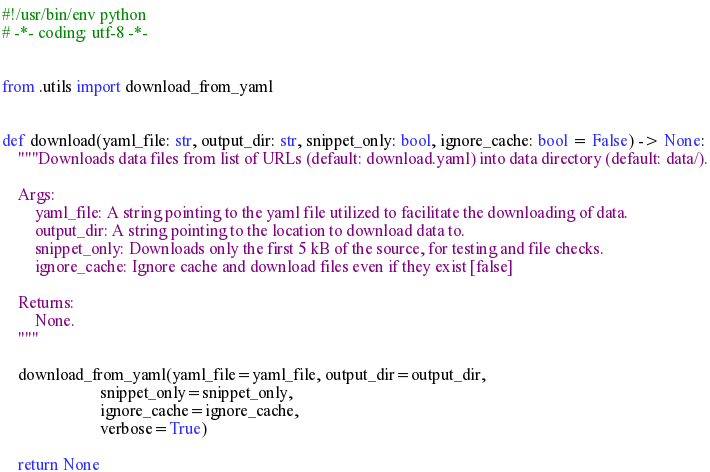Convert code to text. <code><loc_0><loc_0><loc_500><loc_500><_Python_>#!/usr/bin/env python
# -*- coding: utf-8 -*-


from .utils import download_from_yaml


def download(yaml_file: str, output_dir: str, snippet_only: bool, ignore_cache: bool = False) -> None:
    """Downloads data files from list of URLs (default: download.yaml) into data directory (default: data/).

    Args:
        yaml_file: A string pointing to the yaml file utilized to facilitate the downloading of data.
        output_dir: A string pointing to the location to download data to.
        snippet_only: Downloads only the first 5 kB of the source, for testing and file checks.    
        ignore_cache: Ignore cache and download files even if they exist [false]

    Returns:
        None.
    """

    download_from_yaml(yaml_file=yaml_file, output_dir=output_dir,
                        snippet_only=snippet_only,
                        ignore_cache=ignore_cache, 
                        verbose=True)

    return None
</code> 